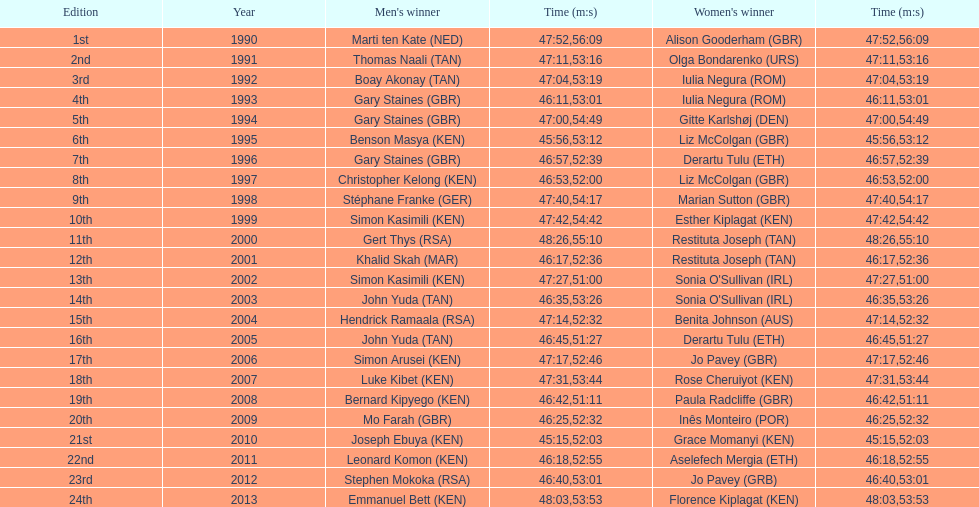What is the number of times, between 1990 and 2013, for britain not to win the men's or women's bupa great south run? 13. 